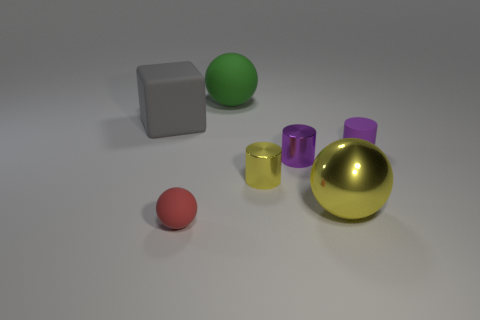Subtract all tiny purple cylinders. How many cylinders are left? 1 Add 2 tiny red things. How many objects exist? 9 Subtract 1 cylinders. How many cylinders are left? 2 Subtract all spheres. How many objects are left? 4 Add 7 small yellow metal cylinders. How many small yellow metal cylinders exist? 8 Subtract all purple cylinders. How many cylinders are left? 1 Subtract 0 purple spheres. How many objects are left? 7 Subtract all red blocks. Subtract all yellow spheres. How many blocks are left? 1 Subtract all gray spheres. How many brown cylinders are left? 0 Subtract all small spheres. Subtract all yellow metallic spheres. How many objects are left? 5 